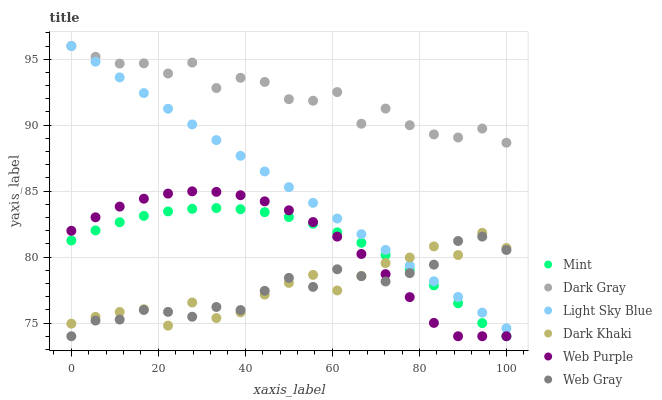Does Web Gray have the minimum area under the curve?
Answer yes or no. Yes. Does Dark Gray have the maximum area under the curve?
Answer yes or no. Yes. Does Dark Gray have the minimum area under the curve?
Answer yes or no. No. Does Web Gray have the maximum area under the curve?
Answer yes or no. No. Is Light Sky Blue the smoothest?
Answer yes or no. Yes. Is Dark Gray the roughest?
Answer yes or no. Yes. Is Web Gray the smoothest?
Answer yes or no. No. Is Web Gray the roughest?
Answer yes or no. No. Does Web Gray have the lowest value?
Answer yes or no. Yes. Does Dark Gray have the lowest value?
Answer yes or no. No. Does Light Sky Blue have the highest value?
Answer yes or no. Yes. Does Web Gray have the highest value?
Answer yes or no. No. Is Mint less than Dark Gray?
Answer yes or no. Yes. Is Dark Gray greater than Dark Khaki?
Answer yes or no. Yes. Does Mint intersect Web Purple?
Answer yes or no. Yes. Is Mint less than Web Purple?
Answer yes or no. No. Is Mint greater than Web Purple?
Answer yes or no. No. Does Mint intersect Dark Gray?
Answer yes or no. No. 